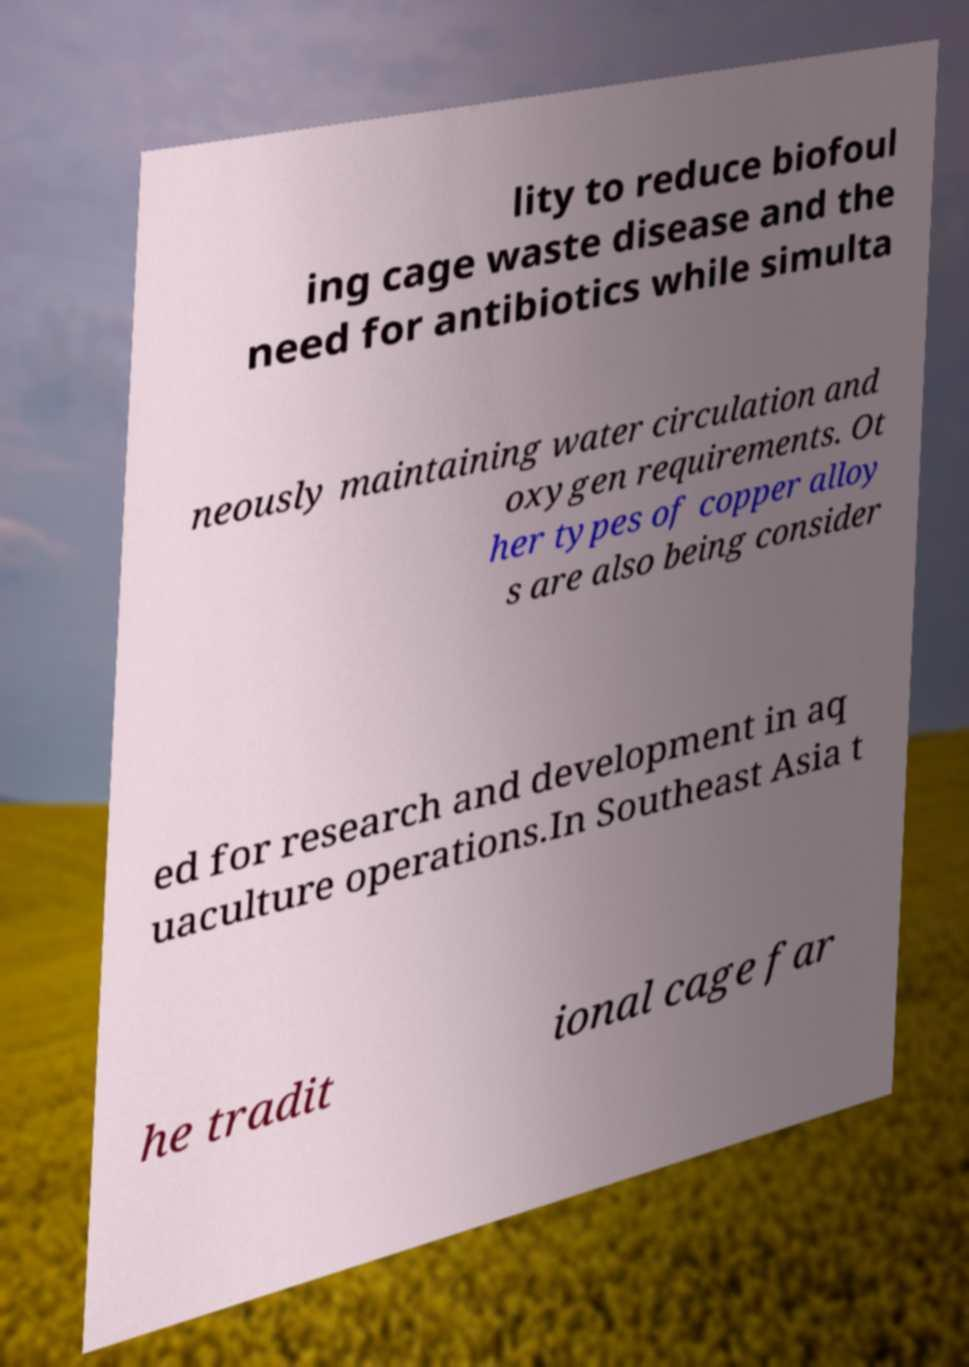What messages or text are displayed in this image? I need them in a readable, typed format. lity to reduce biofoul ing cage waste disease and the need for antibiotics while simulta neously maintaining water circulation and oxygen requirements. Ot her types of copper alloy s are also being consider ed for research and development in aq uaculture operations.In Southeast Asia t he tradit ional cage far 